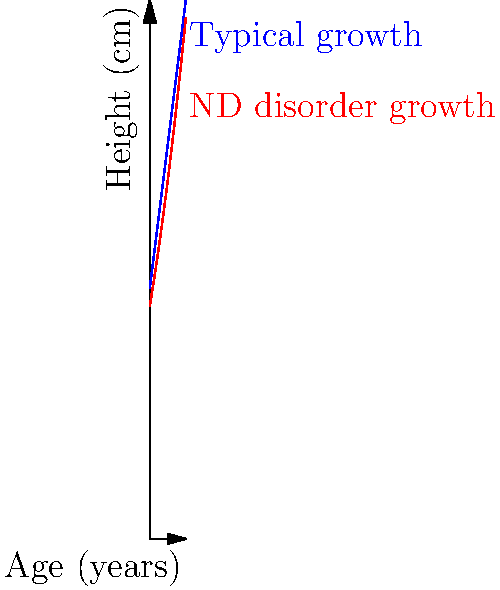A pediatrician is monitoring the growth of children with and without neurodevelopmental (ND) disorders. The graph shows two growth curves: one for typical development (blue) and one for children with a specific ND disorder (red). At what age (in years) does the height difference between the two groups reach 10 cm? To solve this problem, we need to follow these steps:

1. Understand the growth curves:
   - Typical growth (blue): $h_1(x) = 70 + 8x$
   - ND disorder growth (red): $h_2(x) = 65 + 6x + 0.2x^2$
   Where $h$ is height in cm and $x$ is age in years.

2. Calculate the height difference:
   $\Delta h(x) = h_1(x) - h_2(x)$
   $\Delta h(x) = (70 + 8x) - (65 + 6x + 0.2x^2)$
   $\Delta h(x) = 5 + 2x - 0.2x^2$

3. Set up the equation for when the difference is 10 cm:
   $10 = 5 + 2x - 0.2x^2$

4. Rearrange the equation:
   $0.2x^2 - 2x - 5 = 0$

5. Solve the quadratic equation:
   Using the quadratic formula: $x = \frac{-b \pm \sqrt{b^2 - 4ac}}{2a}$
   Where $a = 0.2$, $b = -2$, and $c = -5$

   $x = \frac{2 \pm \sqrt{4 - 4(0.2)(-5)}}{2(0.2)}$
   $x = \frac{2 \pm \sqrt{8}}{0.4}$
   $x = 5 \pm \frac{\sqrt{8}}{0.4}$

6. Simplify and choose the positive solution:
   $x \approx 5 + 7.07 = 12.07$ or $x \approx 5 - 7.07 = -2.07$

   Since age cannot be negative, we choose the positive solution.

Therefore, the height difference reaches 10 cm when the age is approximately 12.07 years.
Answer: 12.07 years 